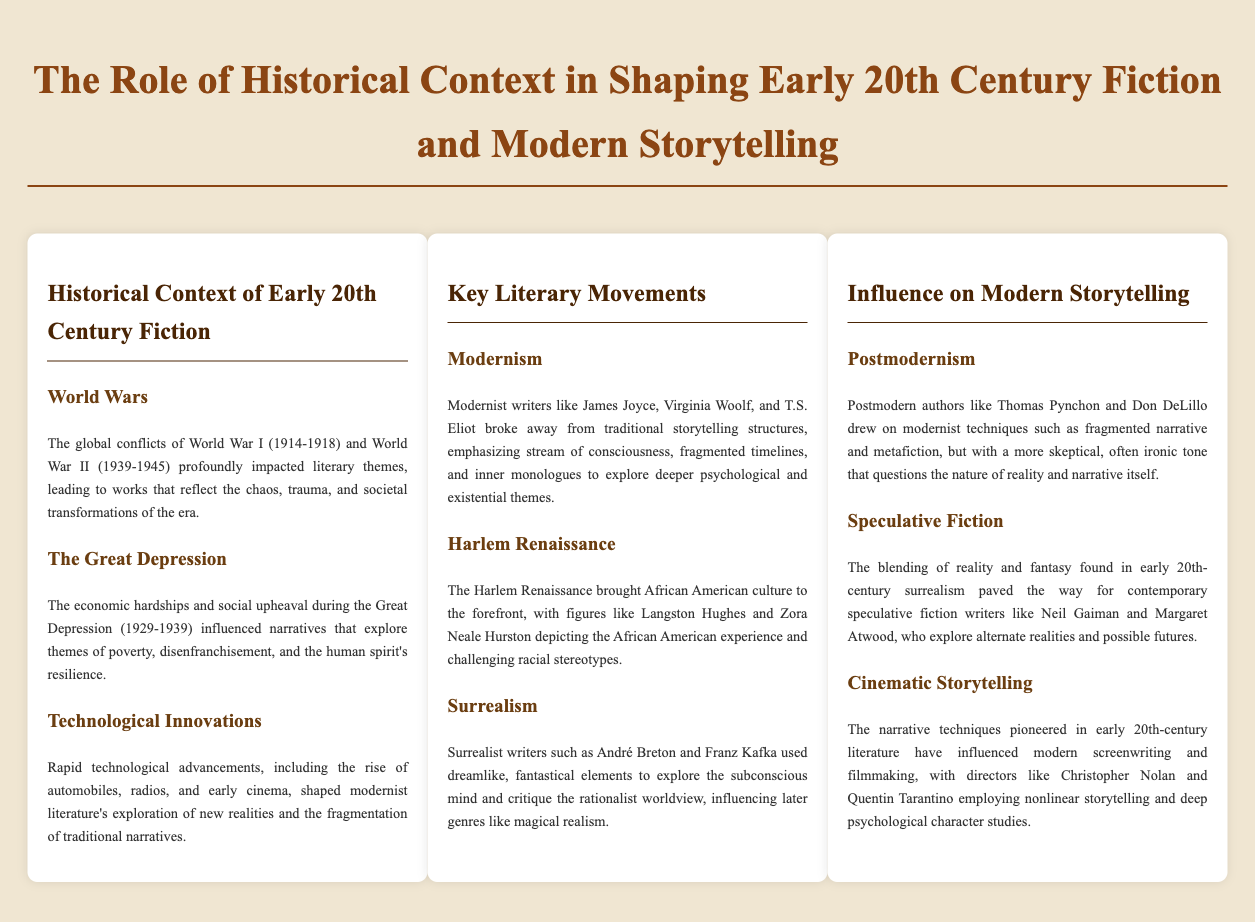What years did World War I occur? The document lists World War I as occurring from 1914 to 1918.
Answer: 1914-1918 Who are two key authors associated with Modernism? The document mentions James Joyce and Virginia Woolf as modernist writers.
Answer: James Joyce, Virginia Woolf What movement highlighted the African American experience? The Harlem Renaissance focused on the African American experience.
Answer: Harlem Renaissance What narrative technique is used by postmodern authors? Postmodern authors employed fragmented narrative techniques.
Answer: Fragmented narrative Which conflict influenced themes of poverty in literature? The Great Depression influenced narratives that explore poverty.
Answer: The Great Depression Who is a contemporary speculative fiction writer mentioned? Neil Gaiman is noted as a contemporary speculative fiction writer.
Answer: Neil Gaiman Which literary movement uses dreamlike elements? Surrealism employs dreamlike, fantastical elements.
Answer: Surrealism What type of storytelling is influenced by early 20th-century literature? Modern screenwriting and filmmaking are influenced by early 20th-century literature.
Answer: Cinematic storytelling What was a major societal theme explored during the World Wars? Chaos and trauma were major themes during the World Wars.
Answer: Chaos, trauma 